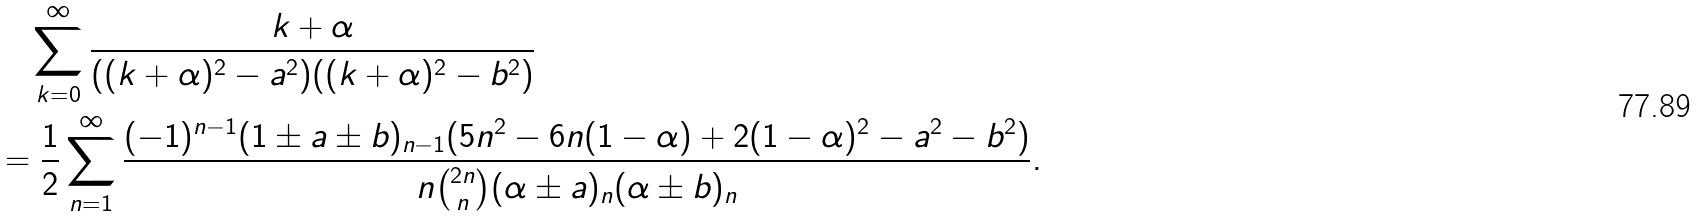<formula> <loc_0><loc_0><loc_500><loc_500>& \quad \sum _ { k = 0 } ^ { \infty } \frac { k + \alpha } { ( ( k + \alpha ) ^ { 2 } - a ^ { 2 } ) ( ( k + \alpha ) ^ { 2 } - b ^ { 2 } ) } \\ & = \frac { 1 } { 2 } \sum _ { n = 1 } ^ { \infty } \frac { ( - 1 ) ^ { n - 1 } ( 1 \pm a \pm b ) _ { n - 1 } ( 5 n ^ { 2 } - 6 n ( 1 - \alpha ) + 2 ( 1 - \alpha ) ^ { 2 } - a ^ { 2 } - b ^ { 2 } ) } { n \binom { 2 n } { n } ( \alpha \pm a ) _ { n } ( \alpha \pm b ) _ { n } } .</formula> 